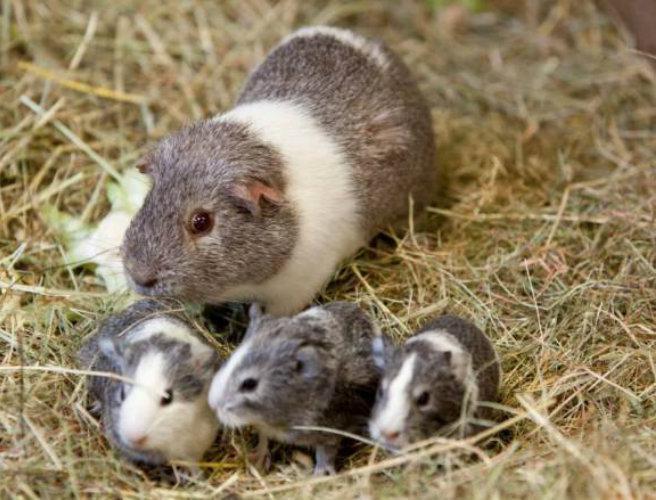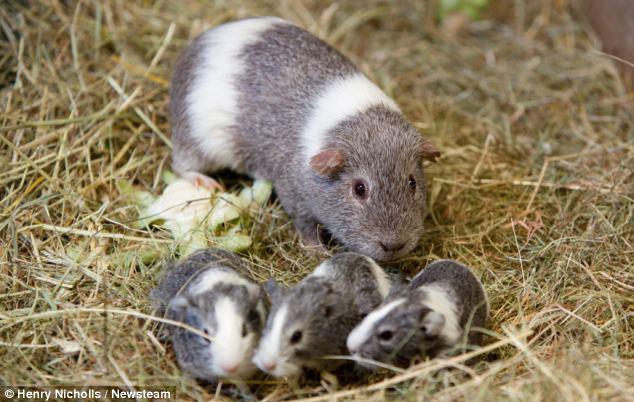The first image is the image on the left, the second image is the image on the right. Assess this claim about the two images: "There are fewer than four guinea pigs in both images.". Correct or not? Answer yes or no. No. 